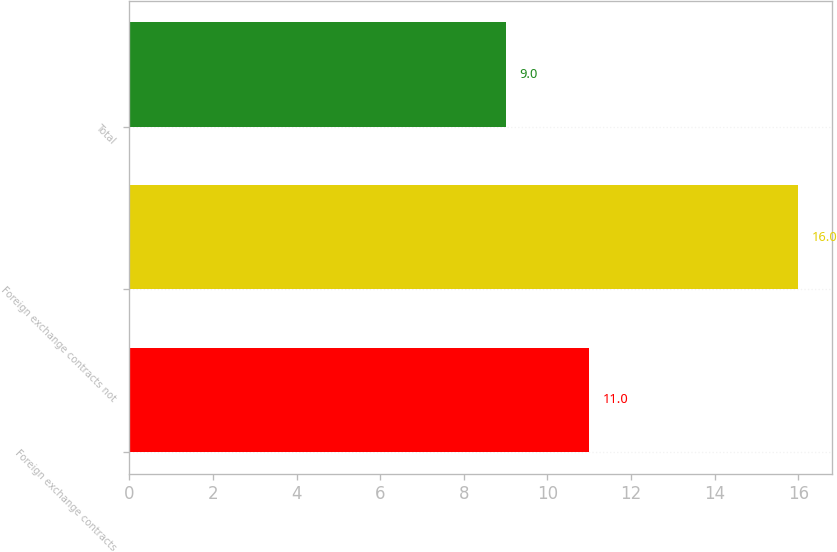Convert chart to OTSL. <chart><loc_0><loc_0><loc_500><loc_500><bar_chart><fcel>Foreign exchange contracts<fcel>Foreign exchange contracts not<fcel>Total<nl><fcel>11<fcel>16<fcel>9<nl></chart> 